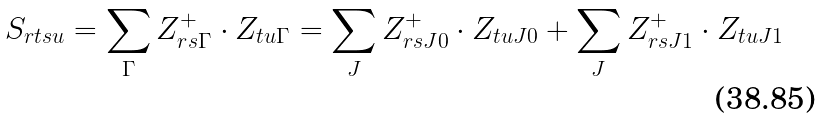Convert formula to latex. <formula><loc_0><loc_0><loc_500><loc_500>S _ { r t s u } = \sum _ { \Gamma } Z _ { r s \Gamma } ^ { + } \cdot Z _ { t u \Gamma } = \sum _ { J } Z _ { r s J 0 } ^ { + } \cdot Z _ { t u J 0 } + \sum _ { J } Z _ { r s J 1 } ^ { + } \cdot Z _ { t u J 1 }</formula> 